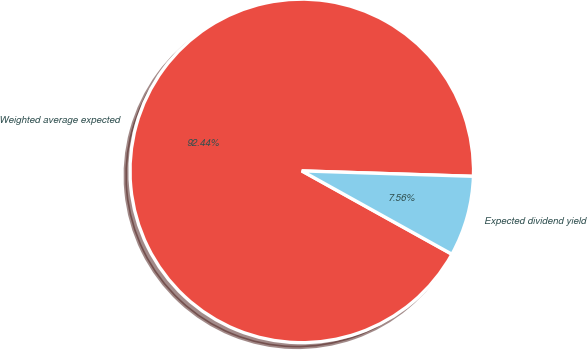Convert chart. <chart><loc_0><loc_0><loc_500><loc_500><pie_chart><fcel>Weighted average expected<fcel>Expected dividend yield<nl><fcel>92.44%<fcel>7.56%<nl></chart> 